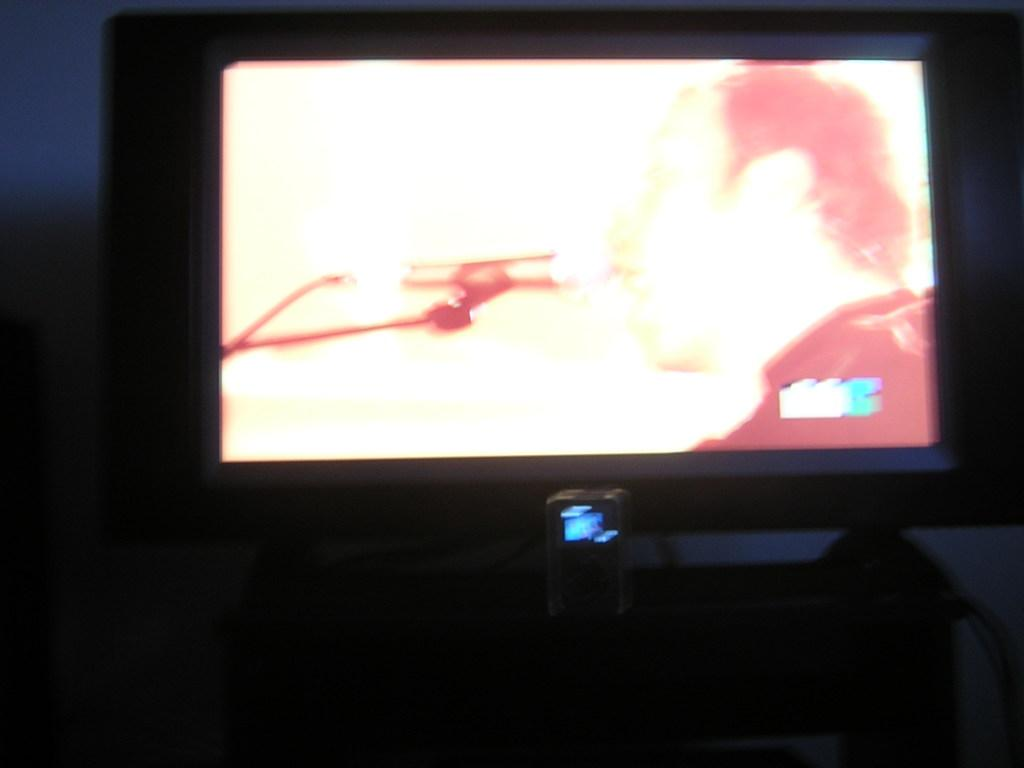What object is present on the table in the image? There is a screen on the table. What can be seen on the screen? A person is visible on the screen. What color is the background of the screen? The background of the screen is blue. How many fish can be seen swimming in the background of the screen? There are no fish visible in the image; the background of the screen is blue. 